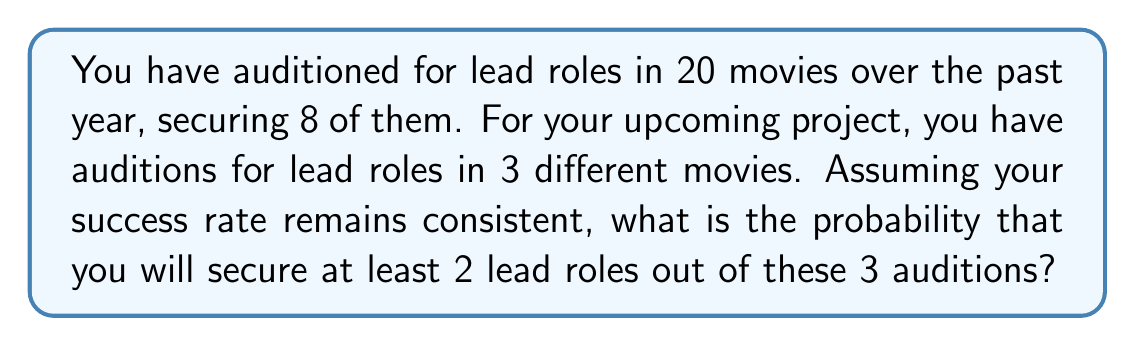Can you answer this question? Let's approach this step-by-step:

1) First, we need to calculate your success rate from past auditions:
   Success rate = $\frac{\text{Number of successful auditions}}{\text{Total number of auditions}} = \frac{8}{20} = 0.4$ or 40%

2) Now, we can treat each audition as an independent Bernoulli trial with p = 0.4 (success probability) and q = 1 - p = 0.6 (failure probability).

3) We want the probability of getting at least 2 successes out of 3 trials. This can happen in two ways:
   - Exactly 2 successes out of 3
   - All 3 successes

4) We can use the Binomial probability formula:
   $P(X = k) = \binom{n}{k} p^k (1-p)^{n-k}$
   where n is the number of trials, k is the number of successes, p is the probability of success.

5) Probability of exactly 2 successes:
   $P(X = 2) = \binom{3}{2} (0.4)^2 (0.6)^1 = 3 \times 0.16 \times 0.6 = 0.288$

6) Probability of 3 successes:
   $P(X = 3) = \binom{3}{3} (0.4)^3 (0.6)^0 = 1 \times 0.064 \times 1 = 0.064$

7) The probability of at least 2 successes is the sum of these probabilities:
   $P(X \geq 2) = P(X = 2) + P(X = 3) = 0.288 + 0.064 = 0.352$

Therefore, the probability of securing at least 2 lead roles out of 3 auditions is 0.352 or 35.2%.
Answer: 0.352 or 35.2% 